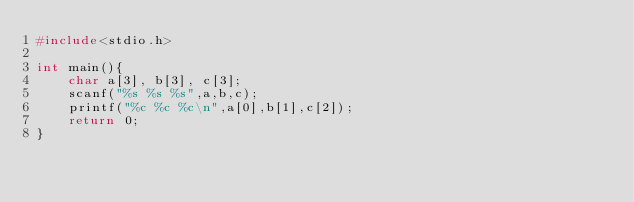<code> <loc_0><loc_0><loc_500><loc_500><_C_>#include<stdio.h>
 
int main(){
    char a[3], b[3], c[3];
    scanf("%s %s %s",a,b,c);
    printf("%c %c %c\n",a[0],b[1],c[2]);
    return 0;
}</code> 